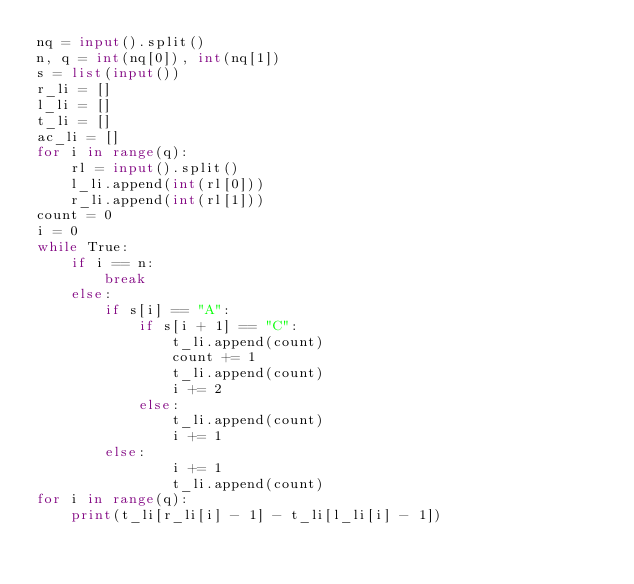<code> <loc_0><loc_0><loc_500><loc_500><_Python_>nq = input().split()
n, q = int(nq[0]), int(nq[1])
s = list(input())
r_li = []
l_li = []
t_li = []
ac_li = []
for i in range(q):
    rl = input().split()
    l_li.append(int(rl[0]))
    r_li.append(int(rl[1]))
count = 0
i = 0
while True:
    if i == n:
        break
    else:
        if s[i] == "A":
            if s[i + 1] == "C":
                t_li.append(count)
                count += 1
                t_li.append(count)
                i += 2
            else:
                t_li.append(count)
                i += 1
        else:
                i += 1
                t_li.append(count)
for i in range(q):
    print(t_li[r_li[i] - 1] - t_li[l_li[i] - 1])







</code> 